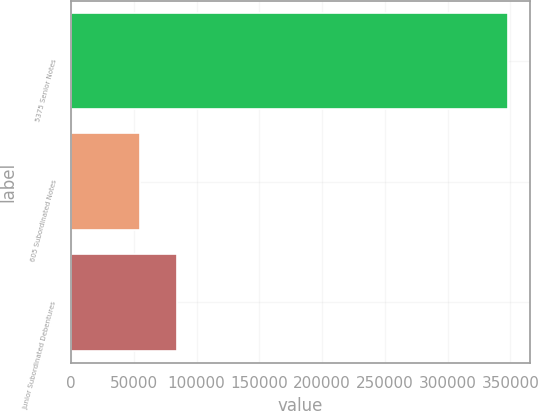Convert chart. <chart><loc_0><loc_0><loc_500><loc_500><bar_chart><fcel>5375 Senior Notes<fcel>605 Subordinated Notes<fcel>Junior Subordinated Debentures<nl><fcel>347793<fcel>55075<fcel>84346.8<nl></chart> 